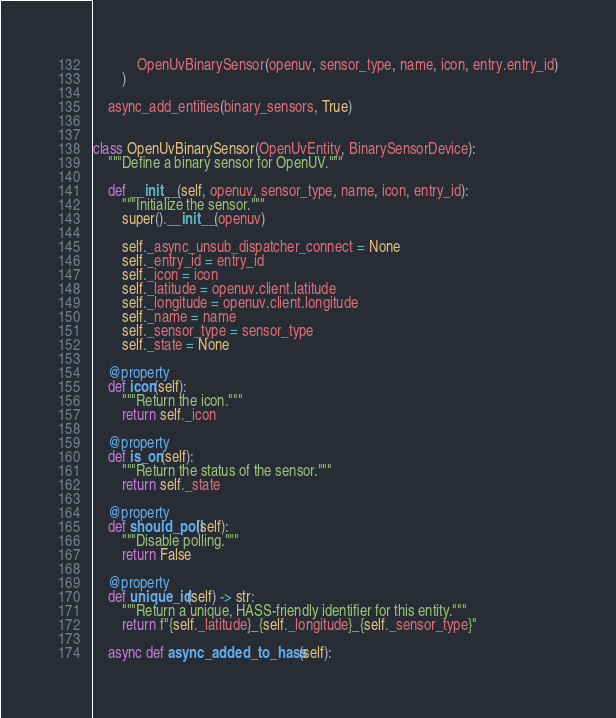Convert code to text. <code><loc_0><loc_0><loc_500><loc_500><_Python_>            OpenUvBinarySensor(openuv, sensor_type, name, icon, entry.entry_id)
        )

    async_add_entities(binary_sensors, True)


class OpenUvBinarySensor(OpenUvEntity, BinarySensorDevice):
    """Define a binary sensor for OpenUV."""

    def __init__(self, openuv, sensor_type, name, icon, entry_id):
        """Initialize the sensor."""
        super().__init__(openuv)

        self._async_unsub_dispatcher_connect = None
        self._entry_id = entry_id
        self._icon = icon
        self._latitude = openuv.client.latitude
        self._longitude = openuv.client.longitude
        self._name = name
        self._sensor_type = sensor_type
        self._state = None

    @property
    def icon(self):
        """Return the icon."""
        return self._icon

    @property
    def is_on(self):
        """Return the status of the sensor."""
        return self._state

    @property
    def should_poll(self):
        """Disable polling."""
        return False

    @property
    def unique_id(self) -> str:
        """Return a unique, HASS-friendly identifier for this entity."""
        return f"{self._latitude}_{self._longitude}_{self._sensor_type}"

    async def async_added_to_hass(self):</code> 